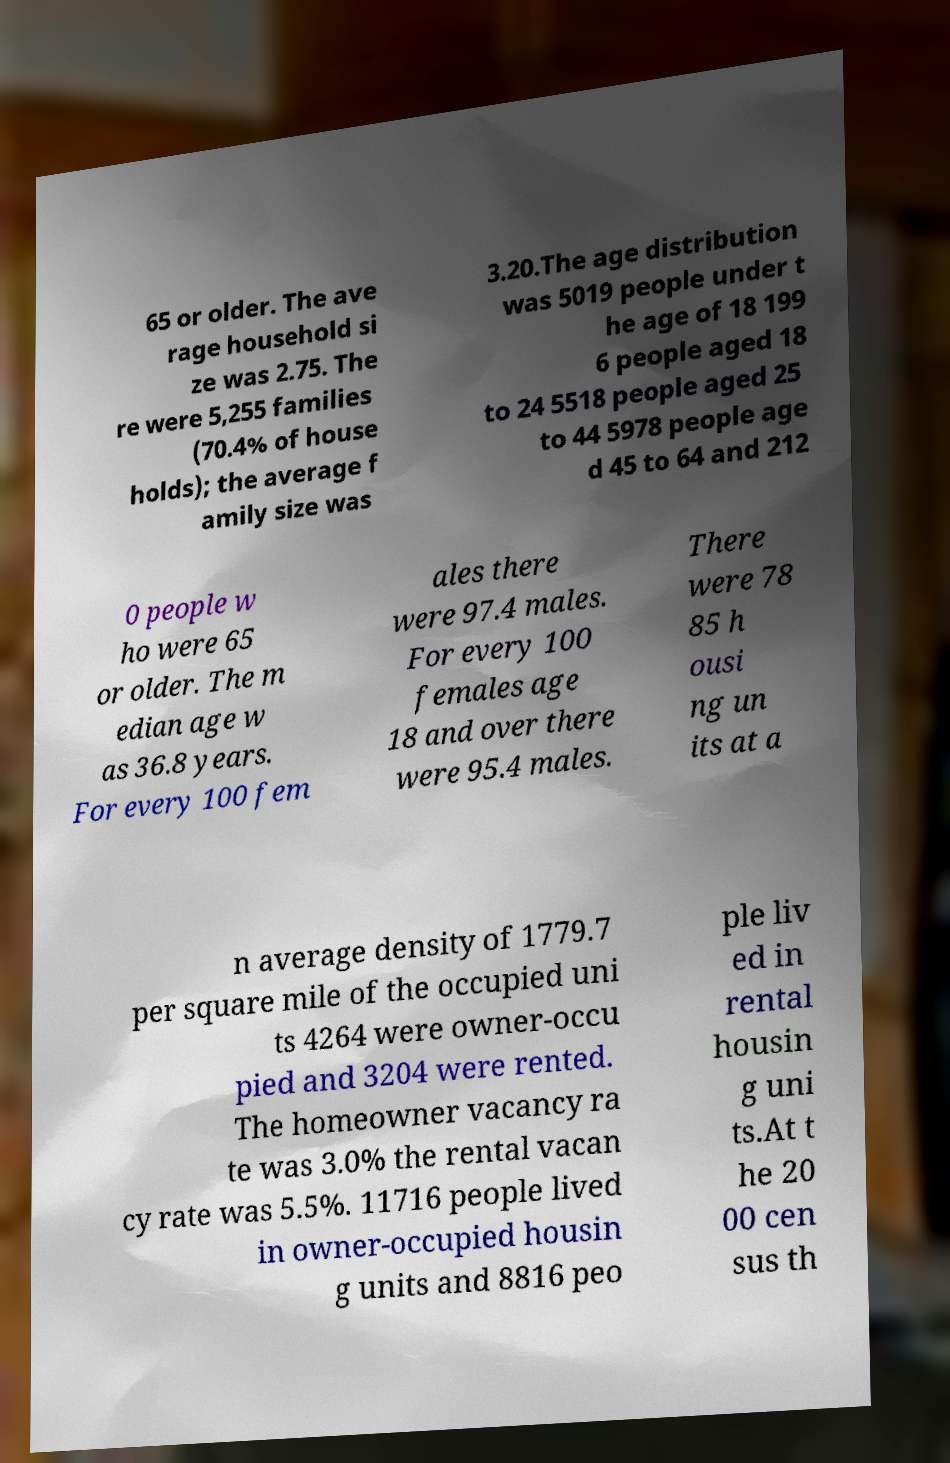There's text embedded in this image that I need extracted. Can you transcribe it verbatim? 65 or older. The ave rage household si ze was 2.75. The re were 5,255 families (70.4% of house holds); the average f amily size was 3.20.The age distribution was 5019 people under t he age of 18 199 6 people aged 18 to 24 5518 people aged 25 to 44 5978 people age d 45 to 64 and 212 0 people w ho were 65 or older. The m edian age w as 36.8 years. For every 100 fem ales there were 97.4 males. For every 100 females age 18 and over there were 95.4 males. There were 78 85 h ousi ng un its at a n average density of 1779.7 per square mile of the occupied uni ts 4264 were owner-occu pied and 3204 were rented. The homeowner vacancy ra te was 3.0% the rental vacan cy rate was 5.5%. 11716 people lived in owner-occupied housin g units and 8816 peo ple liv ed in rental housin g uni ts.At t he 20 00 cen sus th 